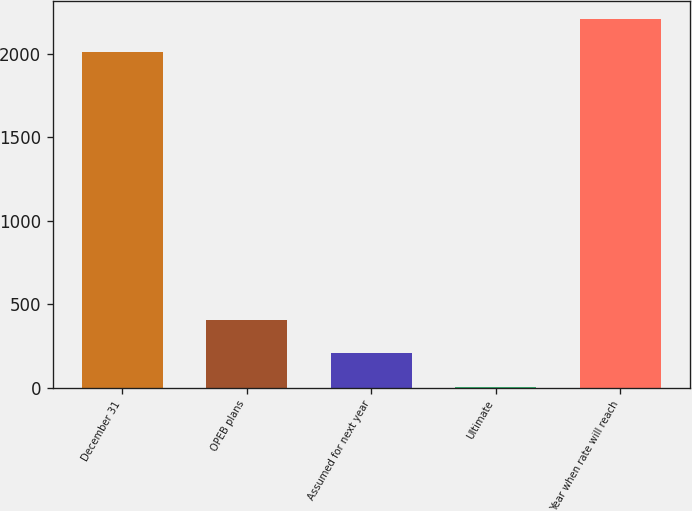Convert chart to OTSL. <chart><loc_0><loc_0><loc_500><loc_500><bar_chart><fcel>December 31<fcel>OPEB plans<fcel>Assumed for next year<fcel>Ultimate<fcel>Year when rate will reach<nl><fcel>2007<fcel>405.2<fcel>204.6<fcel>4<fcel>2207.6<nl></chart> 